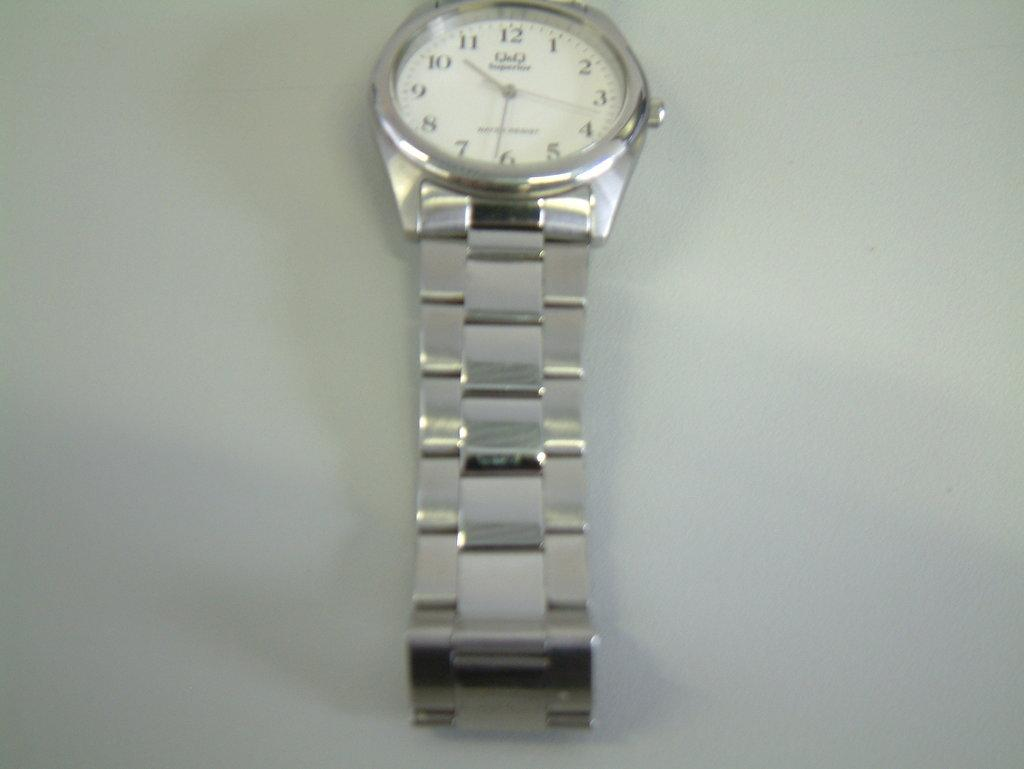<image>
Write a terse but informative summary of the picture. A silver watch with a white face and silver numbers. 